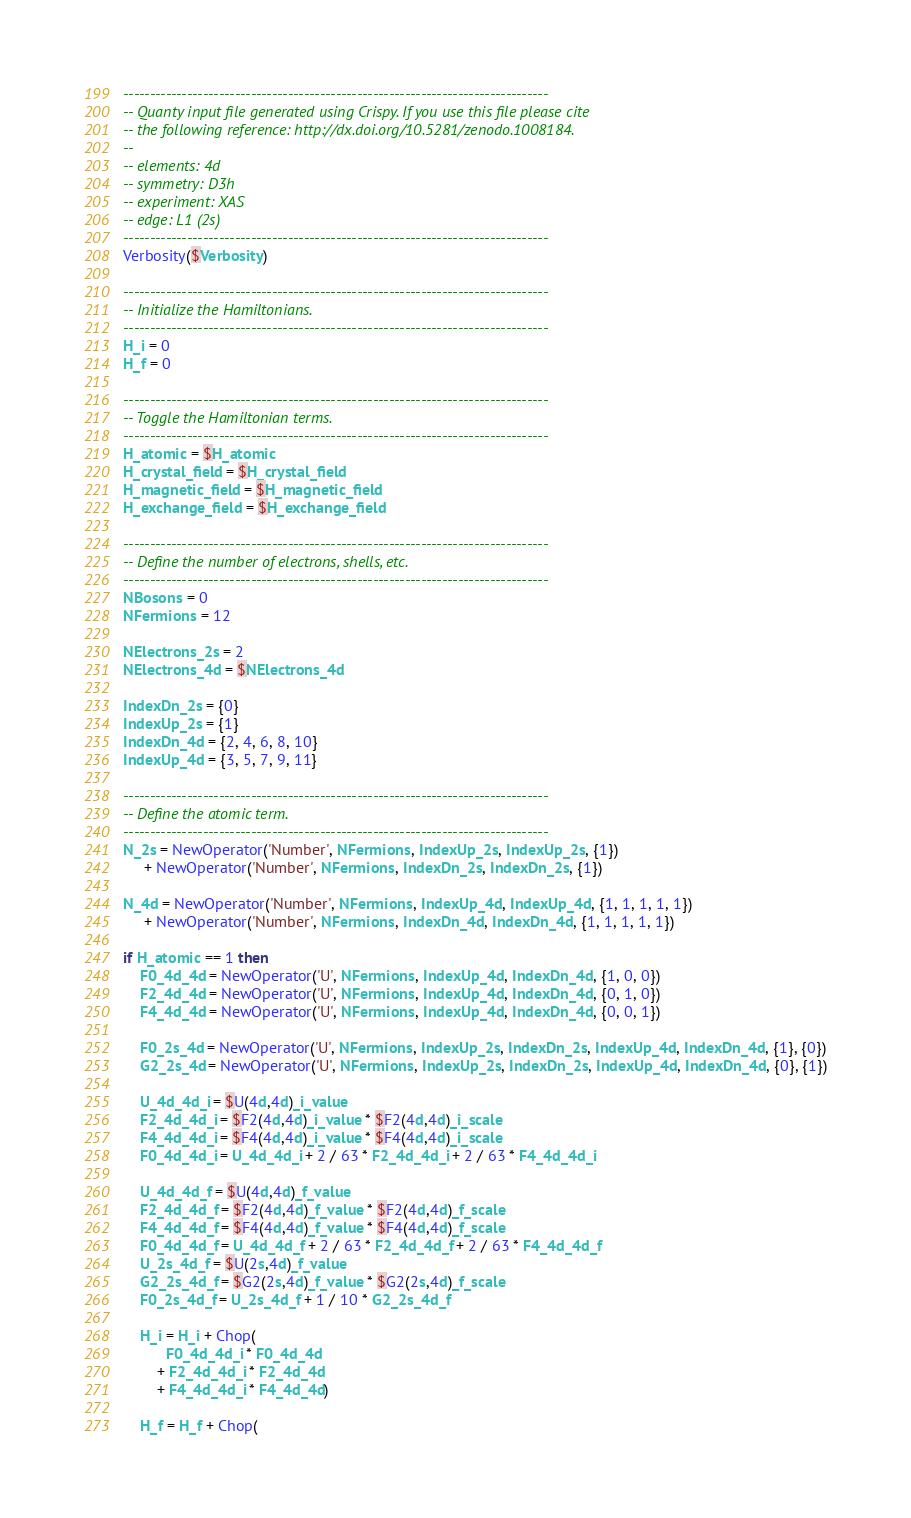<code> <loc_0><loc_0><loc_500><loc_500><_Lua_>--------------------------------------------------------------------------------
-- Quanty input file generated using Crispy. If you use this file please cite
-- the following reference: http://dx.doi.org/10.5281/zenodo.1008184.
--
-- elements: 4d
-- symmetry: D3h
-- experiment: XAS
-- edge: L1 (2s)
--------------------------------------------------------------------------------
Verbosity($Verbosity)

--------------------------------------------------------------------------------
-- Initialize the Hamiltonians.
--------------------------------------------------------------------------------
H_i = 0
H_f = 0

--------------------------------------------------------------------------------
-- Toggle the Hamiltonian terms.
--------------------------------------------------------------------------------
H_atomic = $H_atomic
H_crystal_field = $H_crystal_field
H_magnetic_field = $H_magnetic_field
H_exchange_field = $H_exchange_field

--------------------------------------------------------------------------------
-- Define the number of electrons, shells, etc.
--------------------------------------------------------------------------------
NBosons = 0
NFermions = 12

NElectrons_2s = 2
NElectrons_4d = $NElectrons_4d

IndexDn_2s = {0}
IndexUp_2s = {1}
IndexDn_4d = {2, 4, 6, 8, 10}
IndexUp_4d = {3, 5, 7, 9, 11}

--------------------------------------------------------------------------------
-- Define the atomic term.
--------------------------------------------------------------------------------
N_2s = NewOperator('Number', NFermions, IndexUp_2s, IndexUp_2s, {1})
     + NewOperator('Number', NFermions, IndexDn_2s, IndexDn_2s, {1})

N_4d = NewOperator('Number', NFermions, IndexUp_4d, IndexUp_4d, {1, 1, 1, 1, 1})
     + NewOperator('Number', NFermions, IndexDn_4d, IndexDn_4d, {1, 1, 1, 1, 1})

if H_atomic == 1 then
    F0_4d_4d = NewOperator('U', NFermions, IndexUp_4d, IndexDn_4d, {1, 0, 0})
    F2_4d_4d = NewOperator('U', NFermions, IndexUp_4d, IndexDn_4d, {0, 1, 0})
    F4_4d_4d = NewOperator('U', NFermions, IndexUp_4d, IndexDn_4d, {0, 0, 1})

    F0_2s_4d = NewOperator('U', NFermions, IndexUp_2s, IndexDn_2s, IndexUp_4d, IndexDn_4d, {1}, {0})
    G2_2s_4d = NewOperator('U', NFermions, IndexUp_2s, IndexDn_2s, IndexUp_4d, IndexDn_4d, {0}, {1})

    U_4d_4d_i = $U(4d,4d)_i_value
    F2_4d_4d_i = $F2(4d,4d)_i_value * $F2(4d,4d)_i_scale
    F4_4d_4d_i = $F4(4d,4d)_i_value * $F4(4d,4d)_i_scale
    F0_4d_4d_i = U_4d_4d_i + 2 / 63 * F2_4d_4d_i + 2 / 63 * F4_4d_4d_i

    U_4d_4d_f = $U(4d,4d)_f_value
    F2_4d_4d_f = $F2(4d,4d)_f_value * $F2(4d,4d)_f_scale
    F4_4d_4d_f = $F4(4d,4d)_f_value * $F4(4d,4d)_f_scale
    F0_4d_4d_f = U_4d_4d_f + 2 / 63 * F2_4d_4d_f + 2 / 63 * F4_4d_4d_f
    U_2s_4d_f = $U(2s,4d)_f_value
    G2_2s_4d_f = $G2(2s,4d)_f_value * $G2(2s,4d)_f_scale
    F0_2s_4d_f = U_2s_4d_f + 1 / 10 * G2_2s_4d_f

    H_i = H_i + Chop(
          F0_4d_4d_i * F0_4d_4d
        + F2_4d_4d_i * F2_4d_4d
        + F4_4d_4d_i * F4_4d_4d)

    H_f = H_f + Chop(</code> 